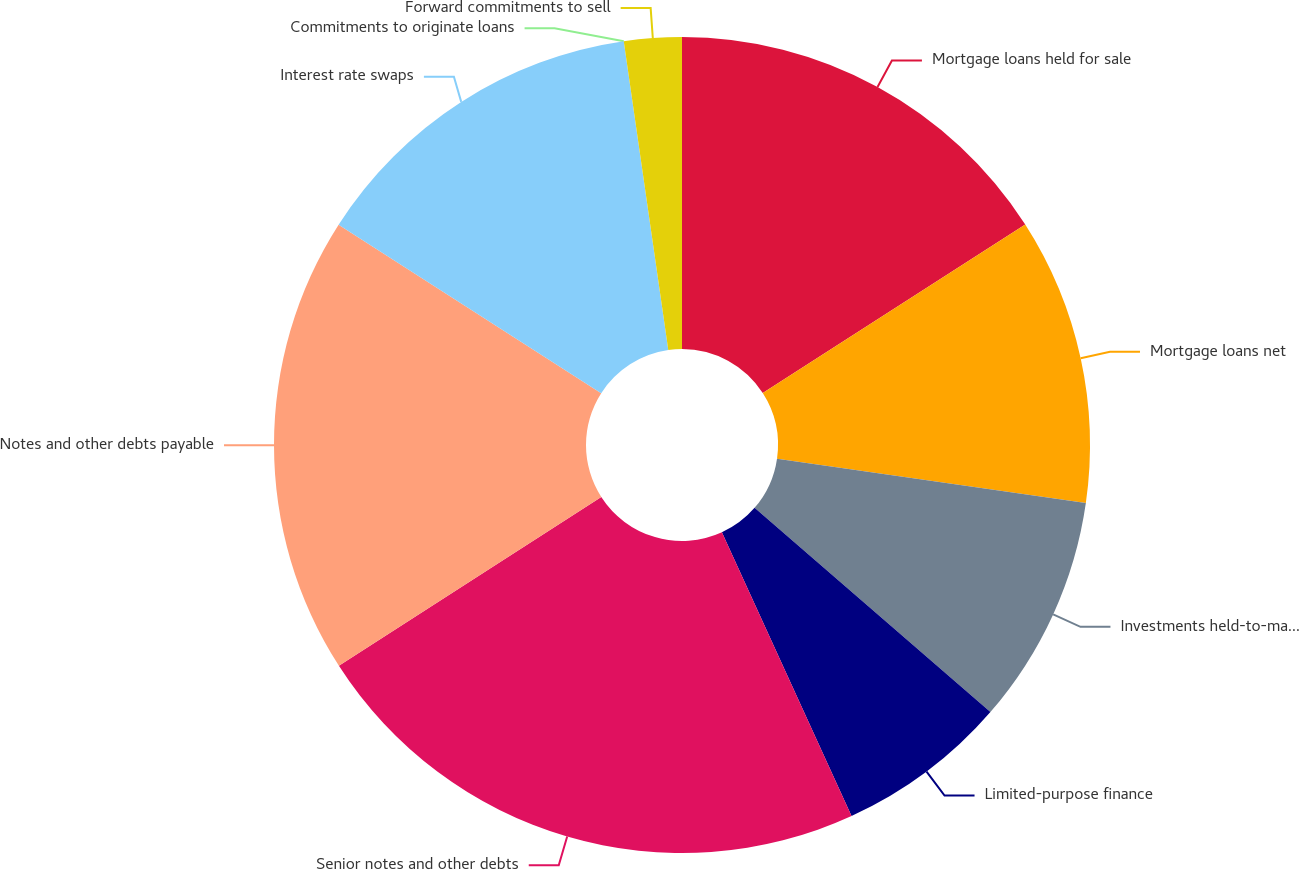Convert chart. <chart><loc_0><loc_0><loc_500><loc_500><pie_chart><fcel>Mortgage loans held for sale<fcel>Mortgage loans net<fcel>Investments held-to-maturity<fcel>Limited-purpose finance<fcel>Senior notes and other debts<fcel>Notes and other debts payable<fcel>Interest rate swaps<fcel>Commitments to originate loans<fcel>Forward commitments to sell<nl><fcel>15.91%<fcel>11.36%<fcel>9.09%<fcel>6.82%<fcel>22.72%<fcel>18.18%<fcel>13.64%<fcel>0.0%<fcel>2.28%<nl></chart> 